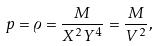<formula> <loc_0><loc_0><loc_500><loc_500>p = \varrho = \frac { M } { X ^ { 2 } Y ^ { 4 } } = \frac { M } { V ^ { 2 } } ,</formula> 